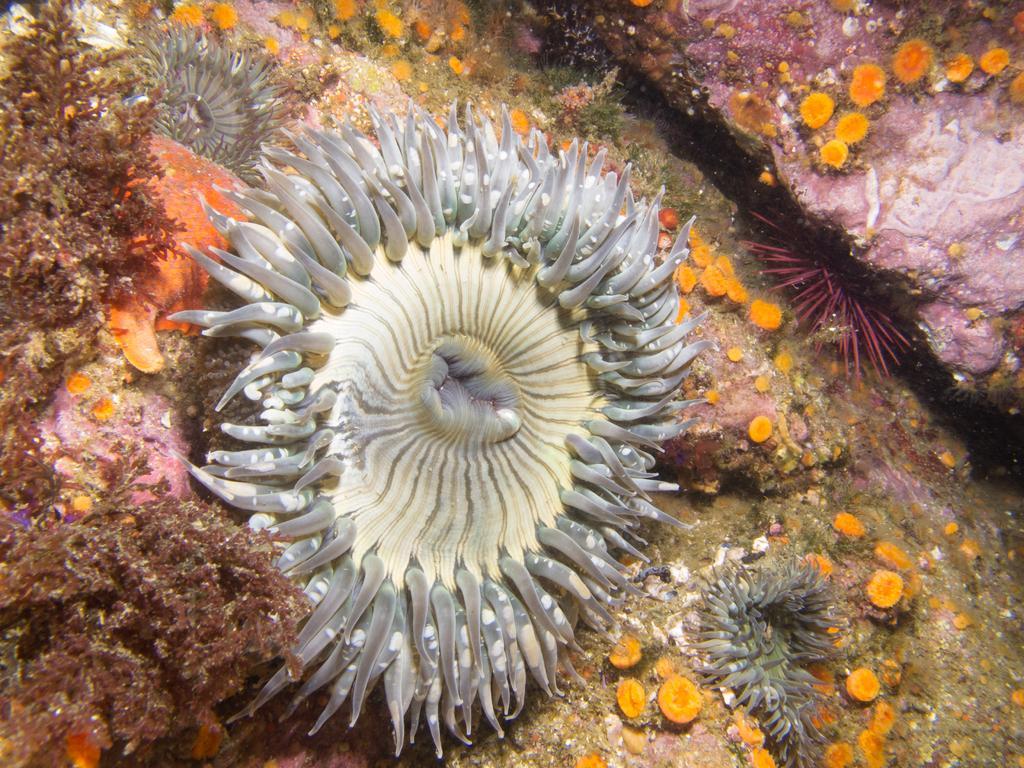Can you describe this image briefly? The picture consists of sea anemones, coral reefs and other aquatic objects. The picture is taken in water. 